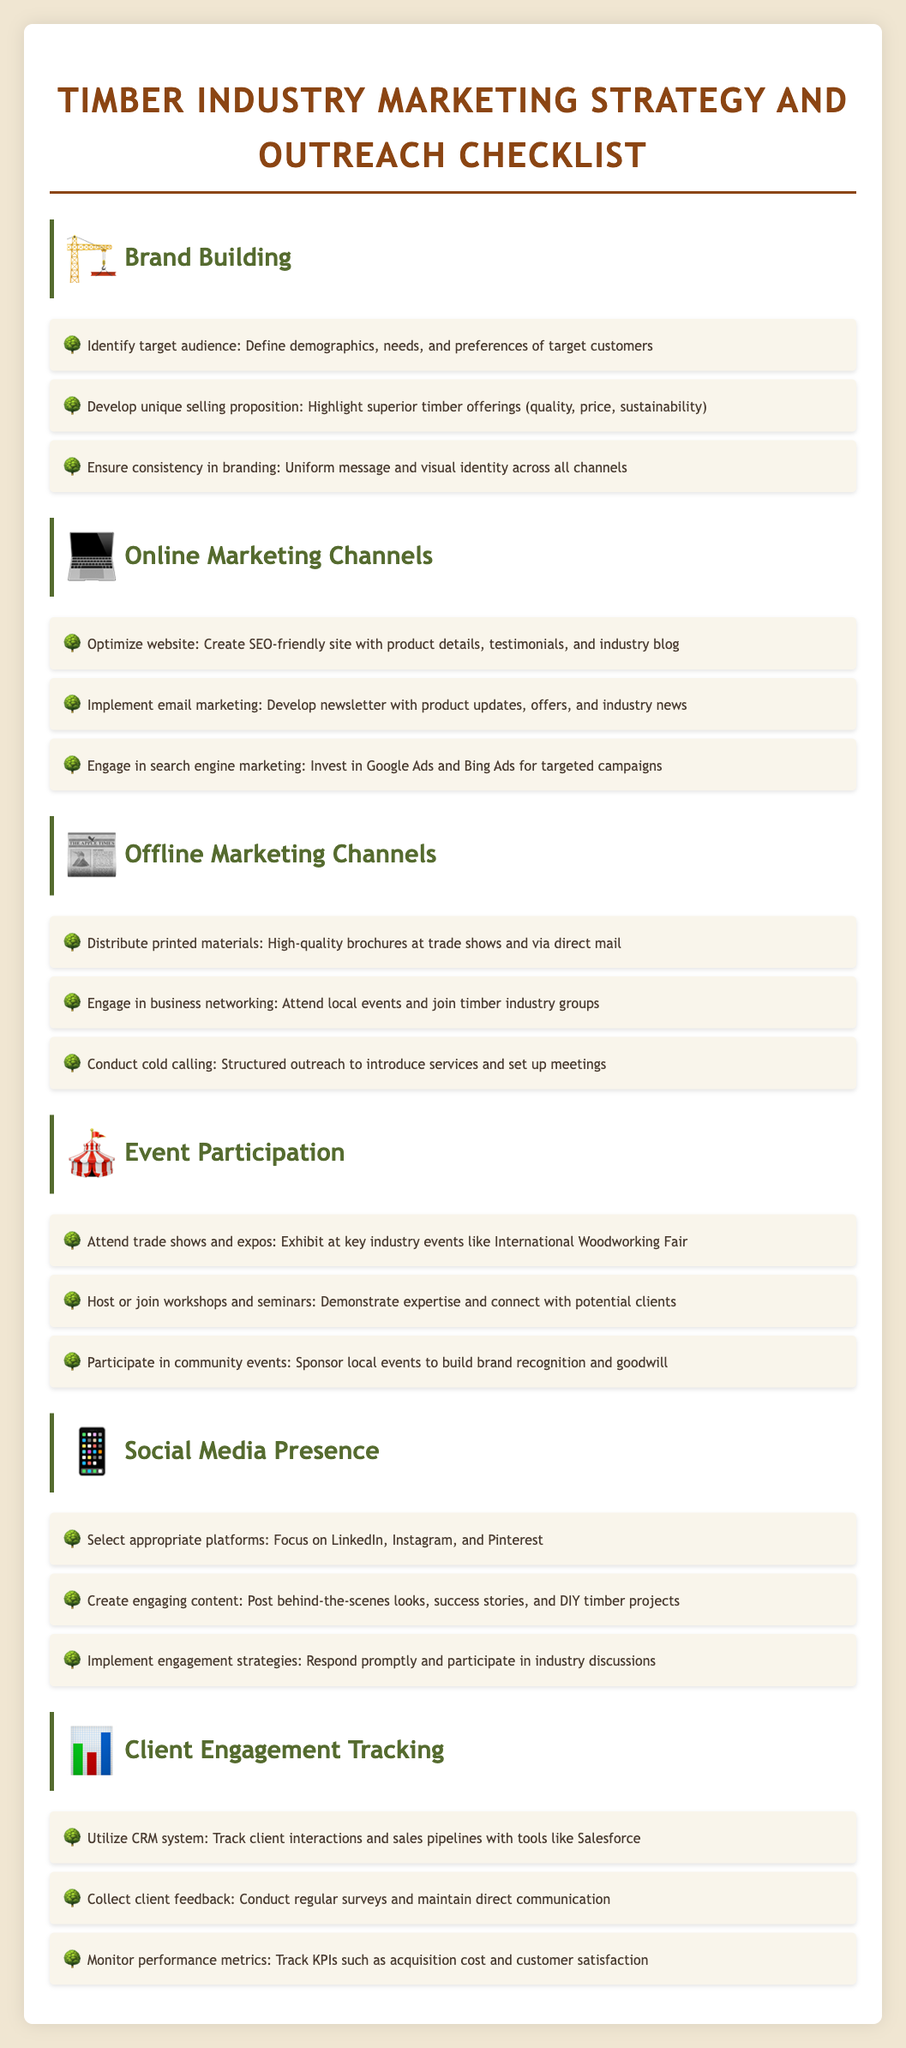what is the first step in brand building? The first step in brand building is to identify the target audience by defining demographics, needs, and preferences of target customers.
Answer: Identify target audience how many online marketing channels are listed? The document lists three online marketing channels under the Online Marketing Channels section.
Answer: Three which social media platforms are recommended? The recommended social media platforms to focus on are LinkedIn, Instagram, and Pinterest.
Answer: LinkedIn, Instagram, and Pinterest what is the purpose of attending trade shows and expos? The purpose of attending trade shows and expos is to exhibit at key industry events like the International Woodworking Fair.
Answer: Exhibit at key industry events what is one method for collecting client feedback? One method for collecting client feedback is to conduct regular surveys.
Answer: Conduct regular surveys how many tactics are suggested under client engagement tracking? There are three tactics suggested under client engagement tracking.
Answer: Three what tactic involves direct outreach to introduce services? The tactic that involves direct outreach to introduce services is cold calling.
Answer: Cold calling what should be created to enhance social media presence? Engaging content should be created to enhance social media presence.
Answer: Create engaging content which tool is mentioned for tracking client interactions? The tool mentioned for tracking client interactions is Salesforce.
Answer: Salesforce 